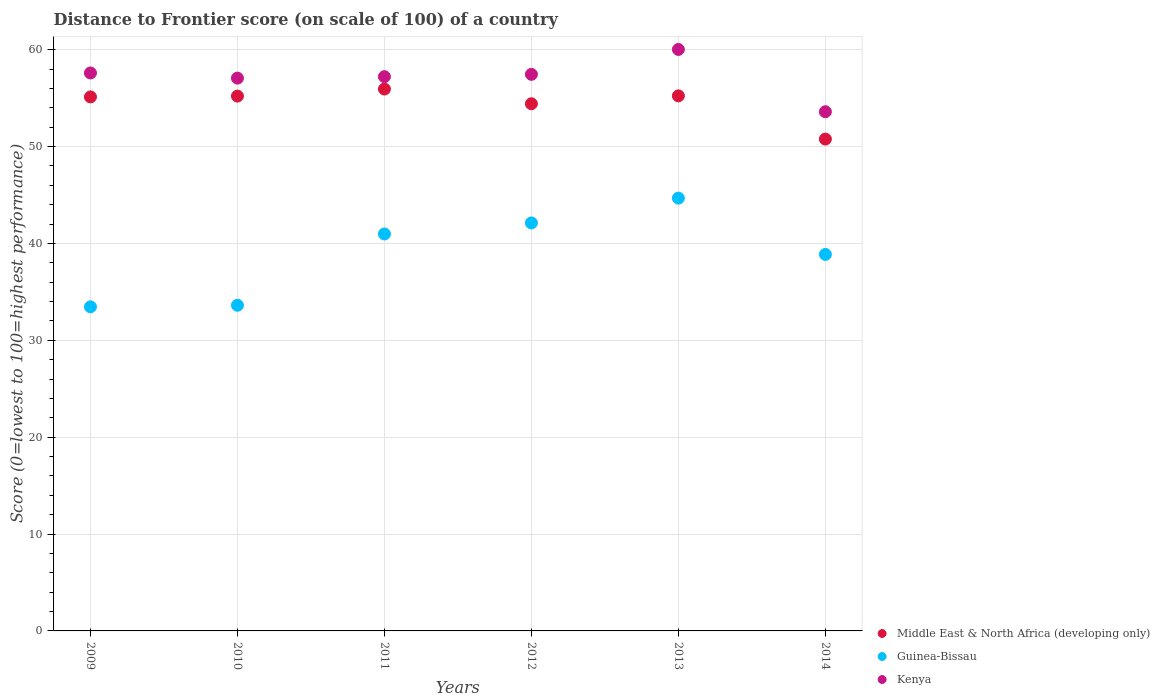How many different coloured dotlines are there?
Give a very brief answer. 3. Is the number of dotlines equal to the number of legend labels?
Your answer should be compact. Yes. What is the distance to frontier score of in Middle East & North Africa (developing only) in 2010?
Ensure brevity in your answer.  55.22. Across all years, what is the maximum distance to frontier score of in Middle East & North Africa (developing only)?
Your answer should be compact. 55.94. Across all years, what is the minimum distance to frontier score of in Guinea-Bissau?
Ensure brevity in your answer.  33.46. In which year was the distance to frontier score of in Guinea-Bissau maximum?
Make the answer very short. 2013. In which year was the distance to frontier score of in Middle East & North Africa (developing only) minimum?
Keep it short and to the point. 2014. What is the total distance to frontier score of in Middle East & North Africa (developing only) in the graph?
Provide a short and direct response. 326.72. What is the difference between the distance to frontier score of in Guinea-Bissau in 2010 and that in 2012?
Give a very brief answer. -8.5. What is the difference between the distance to frontier score of in Guinea-Bissau in 2014 and the distance to frontier score of in Kenya in 2010?
Your answer should be very brief. -18.2. What is the average distance to frontier score of in Middle East & North Africa (developing only) per year?
Offer a terse response. 54.45. In the year 2010, what is the difference between the distance to frontier score of in Kenya and distance to frontier score of in Guinea-Bissau?
Your answer should be very brief. 23.45. What is the ratio of the distance to frontier score of in Guinea-Bissau in 2009 to that in 2012?
Provide a succinct answer. 0.79. What is the difference between the highest and the second highest distance to frontier score of in Guinea-Bissau?
Your answer should be compact. 2.56. What is the difference between the highest and the lowest distance to frontier score of in Kenya?
Offer a very short reply. 6.43. In how many years, is the distance to frontier score of in Middle East & North Africa (developing only) greater than the average distance to frontier score of in Middle East & North Africa (developing only) taken over all years?
Offer a very short reply. 4. Is it the case that in every year, the sum of the distance to frontier score of in Guinea-Bissau and distance to frontier score of in Kenya  is greater than the distance to frontier score of in Middle East & North Africa (developing only)?
Keep it short and to the point. Yes. Does the distance to frontier score of in Guinea-Bissau monotonically increase over the years?
Provide a succinct answer. No. Is the distance to frontier score of in Guinea-Bissau strictly less than the distance to frontier score of in Kenya over the years?
Your answer should be compact. Yes. How many dotlines are there?
Give a very brief answer. 3. How many years are there in the graph?
Give a very brief answer. 6. Does the graph contain any zero values?
Provide a short and direct response. No. Where does the legend appear in the graph?
Your response must be concise. Bottom right. How many legend labels are there?
Ensure brevity in your answer.  3. How are the legend labels stacked?
Your answer should be very brief. Vertical. What is the title of the graph?
Ensure brevity in your answer.  Distance to Frontier score (on scale of 100) of a country. Does "Sudan" appear as one of the legend labels in the graph?
Your answer should be compact. No. What is the label or title of the X-axis?
Give a very brief answer. Years. What is the label or title of the Y-axis?
Your answer should be compact. Score (0=lowest to 100=highest performance). What is the Score (0=lowest to 100=highest performance) of Middle East & North Africa (developing only) in 2009?
Keep it short and to the point. 55.13. What is the Score (0=lowest to 100=highest performance) of Guinea-Bissau in 2009?
Give a very brief answer. 33.46. What is the Score (0=lowest to 100=highest performance) in Kenya in 2009?
Your answer should be compact. 57.6. What is the Score (0=lowest to 100=highest performance) in Middle East & North Africa (developing only) in 2010?
Your response must be concise. 55.22. What is the Score (0=lowest to 100=highest performance) of Guinea-Bissau in 2010?
Provide a succinct answer. 33.62. What is the Score (0=lowest to 100=highest performance) in Kenya in 2010?
Your answer should be compact. 57.07. What is the Score (0=lowest to 100=highest performance) in Middle East & North Africa (developing only) in 2011?
Offer a terse response. 55.94. What is the Score (0=lowest to 100=highest performance) of Guinea-Bissau in 2011?
Make the answer very short. 40.98. What is the Score (0=lowest to 100=highest performance) of Kenya in 2011?
Make the answer very short. 57.22. What is the Score (0=lowest to 100=highest performance) of Middle East & North Africa (developing only) in 2012?
Your answer should be very brief. 54.42. What is the Score (0=lowest to 100=highest performance) in Guinea-Bissau in 2012?
Make the answer very short. 42.12. What is the Score (0=lowest to 100=highest performance) of Kenya in 2012?
Your response must be concise. 57.46. What is the Score (0=lowest to 100=highest performance) of Middle East & North Africa (developing only) in 2013?
Ensure brevity in your answer.  55.24. What is the Score (0=lowest to 100=highest performance) in Guinea-Bissau in 2013?
Provide a short and direct response. 44.68. What is the Score (0=lowest to 100=highest performance) of Kenya in 2013?
Make the answer very short. 60.03. What is the Score (0=lowest to 100=highest performance) in Middle East & North Africa (developing only) in 2014?
Your response must be concise. 50.78. What is the Score (0=lowest to 100=highest performance) in Guinea-Bissau in 2014?
Make the answer very short. 38.87. What is the Score (0=lowest to 100=highest performance) of Kenya in 2014?
Provide a succinct answer. 53.6. Across all years, what is the maximum Score (0=lowest to 100=highest performance) in Middle East & North Africa (developing only)?
Make the answer very short. 55.94. Across all years, what is the maximum Score (0=lowest to 100=highest performance) of Guinea-Bissau?
Ensure brevity in your answer.  44.68. Across all years, what is the maximum Score (0=lowest to 100=highest performance) of Kenya?
Your answer should be very brief. 60.03. Across all years, what is the minimum Score (0=lowest to 100=highest performance) of Middle East & North Africa (developing only)?
Make the answer very short. 50.78. Across all years, what is the minimum Score (0=lowest to 100=highest performance) of Guinea-Bissau?
Provide a succinct answer. 33.46. Across all years, what is the minimum Score (0=lowest to 100=highest performance) in Kenya?
Provide a succinct answer. 53.6. What is the total Score (0=lowest to 100=highest performance) in Middle East & North Africa (developing only) in the graph?
Provide a short and direct response. 326.72. What is the total Score (0=lowest to 100=highest performance) in Guinea-Bissau in the graph?
Offer a very short reply. 233.73. What is the total Score (0=lowest to 100=highest performance) in Kenya in the graph?
Your answer should be very brief. 342.98. What is the difference between the Score (0=lowest to 100=highest performance) of Middle East & North Africa (developing only) in 2009 and that in 2010?
Ensure brevity in your answer.  -0.08. What is the difference between the Score (0=lowest to 100=highest performance) of Guinea-Bissau in 2009 and that in 2010?
Keep it short and to the point. -0.16. What is the difference between the Score (0=lowest to 100=highest performance) in Kenya in 2009 and that in 2010?
Provide a short and direct response. 0.53. What is the difference between the Score (0=lowest to 100=highest performance) of Middle East & North Africa (developing only) in 2009 and that in 2011?
Provide a short and direct response. -0.81. What is the difference between the Score (0=lowest to 100=highest performance) in Guinea-Bissau in 2009 and that in 2011?
Provide a short and direct response. -7.52. What is the difference between the Score (0=lowest to 100=highest performance) of Kenya in 2009 and that in 2011?
Your answer should be very brief. 0.38. What is the difference between the Score (0=lowest to 100=highest performance) in Middle East & North Africa (developing only) in 2009 and that in 2012?
Offer a very short reply. 0.71. What is the difference between the Score (0=lowest to 100=highest performance) in Guinea-Bissau in 2009 and that in 2012?
Keep it short and to the point. -8.66. What is the difference between the Score (0=lowest to 100=highest performance) in Kenya in 2009 and that in 2012?
Keep it short and to the point. 0.14. What is the difference between the Score (0=lowest to 100=highest performance) of Middle East & North Africa (developing only) in 2009 and that in 2013?
Your response must be concise. -0.11. What is the difference between the Score (0=lowest to 100=highest performance) of Guinea-Bissau in 2009 and that in 2013?
Ensure brevity in your answer.  -11.22. What is the difference between the Score (0=lowest to 100=highest performance) of Kenya in 2009 and that in 2013?
Keep it short and to the point. -2.43. What is the difference between the Score (0=lowest to 100=highest performance) in Middle East & North Africa (developing only) in 2009 and that in 2014?
Keep it short and to the point. 4.35. What is the difference between the Score (0=lowest to 100=highest performance) in Guinea-Bissau in 2009 and that in 2014?
Make the answer very short. -5.41. What is the difference between the Score (0=lowest to 100=highest performance) of Kenya in 2009 and that in 2014?
Keep it short and to the point. 4. What is the difference between the Score (0=lowest to 100=highest performance) of Middle East & North Africa (developing only) in 2010 and that in 2011?
Make the answer very short. -0.73. What is the difference between the Score (0=lowest to 100=highest performance) in Guinea-Bissau in 2010 and that in 2011?
Give a very brief answer. -7.36. What is the difference between the Score (0=lowest to 100=highest performance) of Middle East & North Africa (developing only) in 2010 and that in 2012?
Offer a terse response. 0.79. What is the difference between the Score (0=lowest to 100=highest performance) of Kenya in 2010 and that in 2012?
Your answer should be compact. -0.39. What is the difference between the Score (0=lowest to 100=highest performance) of Middle East & North Africa (developing only) in 2010 and that in 2013?
Your response must be concise. -0.02. What is the difference between the Score (0=lowest to 100=highest performance) in Guinea-Bissau in 2010 and that in 2013?
Your response must be concise. -11.06. What is the difference between the Score (0=lowest to 100=highest performance) of Kenya in 2010 and that in 2013?
Your response must be concise. -2.96. What is the difference between the Score (0=lowest to 100=highest performance) in Middle East & North Africa (developing only) in 2010 and that in 2014?
Make the answer very short. 4.44. What is the difference between the Score (0=lowest to 100=highest performance) of Guinea-Bissau in 2010 and that in 2014?
Your answer should be compact. -5.25. What is the difference between the Score (0=lowest to 100=highest performance) in Kenya in 2010 and that in 2014?
Provide a succinct answer. 3.47. What is the difference between the Score (0=lowest to 100=highest performance) of Middle East & North Africa (developing only) in 2011 and that in 2012?
Give a very brief answer. 1.52. What is the difference between the Score (0=lowest to 100=highest performance) of Guinea-Bissau in 2011 and that in 2012?
Offer a very short reply. -1.14. What is the difference between the Score (0=lowest to 100=highest performance) in Kenya in 2011 and that in 2012?
Your response must be concise. -0.24. What is the difference between the Score (0=lowest to 100=highest performance) of Middle East & North Africa (developing only) in 2011 and that in 2013?
Your answer should be compact. 0.71. What is the difference between the Score (0=lowest to 100=highest performance) of Guinea-Bissau in 2011 and that in 2013?
Offer a terse response. -3.7. What is the difference between the Score (0=lowest to 100=highest performance) in Kenya in 2011 and that in 2013?
Provide a succinct answer. -2.81. What is the difference between the Score (0=lowest to 100=highest performance) of Middle East & North Africa (developing only) in 2011 and that in 2014?
Ensure brevity in your answer.  5.17. What is the difference between the Score (0=lowest to 100=highest performance) of Guinea-Bissau in 2011 and that in 2014?
Provide a short and direct response. 2.11. What is the difference between the Score (0=lowest to 100=highest performance) in Kenya in 2011 and that in 2014?
Offer a terse response. 3.62. What is the difference between the Score (0=lowest to 100=highest performance) in Middle East & North Africa (developing only) in 2012 and that in 2013?
Offer a very short reply. -0.81. What is the difference between the Score (0=lowest to 100=highest performance) of Guinea-Bissau in 2012 and that in 2013?
Make the answer very short. -2.56. What is the difference between the Score (0=lowest to 100=highest performance) of Kenya in 2012 and that in 2013?
Offer a very short reply. -2.57. What is the difference between the Score (0=lowest to 100=highest performance) in Middle East & North Africa (developing only) in 2012 and that in 2014?
Offer a terse response. 3.65. What is the difference between the Score (0=lowest to 100=highest performance) of Guinea-Bissau in 2012 and that in 2014?
Offer a terse response. 3.25. What is the difference between the Score (0=lowest to 100=highest performance) of Kenya in 2012 and that in 2014?
Provide a short and direct response. 3.86. What is the difference between the Score (0=lowest to 100=highest performance) of Middle East & North Africa (developing only) in 2013 and that in 2014?
Give a very brief answer. 4.46. What is the difference between the Score (0=lowest to 100=highest performance) in Guinea-Bissau in 2013 and that in 2014?
Your response must be concise. 5.81. What is the difference between the Score (0=lowest to 100=highest performance) of Kenya in 2013 and that in 2014?
Provide a short and direct response. 6.43. What is the difference between the Score (0=lowest to 100=highest performance) in Middle East & North Africa (developing only) in 2009 and the Score (0=lowest to 100=highest performance) in Guinea-Bissau in 2010?
Your answer should be very brief. 21.51. What is the difference between the Score (0=lowest to 100=highest performance) of Middle East & North Africa (developing only) in 2009 and the Score (0=lowest to 100=highest performance) of Kenya in 2010?
Your answer should be compact. -1.94. What is the difference between the Score (0=lowest to 100=highest performance) in Guinea-Bissau in 2009 and the Score (0=lowest to 100=highest performance) in Kenya in 2010?
Offer a terse response. -23.61. What is the difference between the Score (0=lowest to 100=highest performance) in Middle East & North Africa (developing only) in 2009 and the Score (0=lowest to 100=highest performance) in Guinea-Bissau in 2011?
Provide a succinct answer. 14.15. What is the difference between the Score (0=lowest to 100=highest performance) in Middle East & North Africa (developing only) in 2009 and the Score (0=lowest to 100=highest performance) in Kenya in 2011?
Keep it short and to the point. -2.09. What is the difference between the Score (0=lowest to 100=highest performance) in Guinea-Bissau in 2009 and the Score (0=lowest to 100=highest performance) in Kenya in 2011?
Offer a terse response. -23.76. What is the difference between the Score (0=lowest to 100=highest performance) of Middle East & North Africa (developing only) in 2009 and the Score (0=lowest to 100=highest performance) of Guinea-Bissau in 2012?
Offer a very short reply. 13.01. What is the difference between the Score (0=lowest to 100=highest performance) of Middle East & North Africa (developing only) in 2009 and the Score (0=lowest to 100=highest performance) of Kenya in 2012?
Your response must be concise. -2.33. What is the difference between the Score (0=lowest to 100=highest performance) in Middle East & North Africa (developing only) in 2009 and the Score (0=lowest to 100=highest performance) in Guinea-Bissau in 2013?
Your response must be concise. 10.45. What is the difference between the Score (0=lowest to 100=highest performance) of Middle East & North Africa (developing only) in 2009 and the Score (0=lowest to 100=highest performance) of Kenya in 2013?
Keep it short and to the point. -4.9. What is the difference between the Score (0=lowest to 100=highest performance) of Guinea-Bissau in 2009 and the Score (0=lowest to 100=highest performance) of Kenya in 2013?
Your response must be concise. -26.57. What is the difference between the Score (0=lowest to 100=highest performance) of Middle East & North Africa (developing only) in 2009 and the Score (0=lowest to 100=highest performance) of Guinea-Bissau in 2014?
Keep it short and to the point. 16.26. What is the difference between the Score (0=lowest to 100=highest performance) of Middle East & North Africa (developing only) in 2009 and the Score (0=lowest to 100=highest performance) of Kenya in 2014?
Your answer should be very brief. 1.53. What is the difference between the Score (0=lowest to 100=highest performance) in Guinea-Bissau in 2009 and the Score (0=lowest to 100=highest performance) in Kenya in 2014?
Your answer should be compact. -20.14. What is the difference between the Score (0=lowest to 100=highest performance) of Middle East & North Africa (developing only) in 2010 and the Score (0=lowest to 100=highest performance) of Guinea-Bissau in 2011?
Offer a terse response. 14.23. What is the difference between the Score (0=lowest to 100=highest performance) in Middle East & North Africa (developing only) in 2010 and the Score (0=lowest to 100=highest performance) in Kenya in 2011?
Your answer should be very brief. -2. What is the difference between the Score (0=lowest to 100=highest performance) in Guinea-Bissau in 2010 and the Score (0=lowest to 100=highest performance) in Kenya in 2011?
Make the answer very short. -23.6. What is the difference between the Score (0=lowest to 100=highest performance) in Middle East & North Africa (developing only) in 2010 and the Score (0=lowest to 100=highest performance) in Guinea-Bissau in 2012?
Make the answer very short. 13.1. What is the difference between the Score (0=lowest to 100=highest performance) in Middle East & North Africa (developing only) in 2010 and the Score (0=lowest to 100=highest performance) in Kenya in 2012?
Provide a succinct answer. -2.25. What is the difference between the Score (0=lowest to 100=highest performance) of Guinea-Bissau in 2010 and the Score (0=lowest to 100=highest performance) of Kenya in 2012?
Offer a terse response. -23.84. What is the difference between the Score (0=lowest to 100=highest performance) of Middle East & North Africa (developing only) in 2010 and the Score (0=lowest to 100=highest performance) of Guinea-Bissau in 2013?
Your response must be concise. 10.54. What is the difference between the Score (0=lowest to 100=highest performance) in Middle East & North Africa (developing only) in 2010 and the Score (0=lowest to 100=highest performance) in Kenya in 2013?
Provide a succinct answer. -4.82. What is the difference between the Score (0=lowest to 100=highest performance) of Guinea-Bissau in 2010 and the Score (0=lowest to 100=highest performance) of Kenya in 2013?
Make the answer very short. -26.41. What is the difference between the Score (0=lowest to 100=highest performance) in Middle East & North Africa (developing only) in 2010 and the Score (0=lowest to 100=highest performance) in Guinea-Bissau in 2014?
Your answer should be very brief. 16.34. What is the difference between the Score (0=lowest to 100=highest performance) in Middle East & North Africa (developing only) in 2010 and the Score (0=lowest to 100=highest performance) in Kenya in 2014?
Offer a very short reply. 1.61. What is the difference between the Score (0=lowest to 100=highest performance) in Guinea-Bissau in 2010 and the Score (0=lowest to 100=highest performance) in Kenya in 2014?
Provide a short and direct response. -19.98. What is the difference between the Score (0=lowest to 100=highest performance) of Middle East & North Africa (developing only) in 2011 and the Score (0=lowest to 100=highest performance) of Guinea-Bissau in 2012?
Your answer should be compact. 13.82. What is the difference between the Score (0=lowest to 100=highest performance) of Middle East & North Africa (developing only) in 2011 and the Score (0=lowest to 100=highest performance) of Kenya in 2012?
Your answer should be compact. -1.52. What is the difference between the Score (0=lowest to 100=highest performance) of Guinea-Bissau in 2011 and the Score (0=lowest to 100=highest performance) of Kenya in 2012?
Your response must be concise. -16.48. What is the difference between the Score (0=lowest to 100=highest performance) in Middle East & North Africa (developing only) in 2011 and the Score (0=lowest to 100=highest performance) in Guinea-Bissau in 2013?
Give a very brief answer. 11.26. What is the difference between the Score (0=lowest to 100=highest performance) of Middle East & North Africa (developing only) in 2011 and the Score (0=lowest to 100=highest performance) of Kenya in 2013?
Give a very brief answer. -4.09. What is the difference between the Score (0=lowest to 100=highest performance) in Guinea-Bissau in 2011 and the Score (0=lowest to 100=highest performance) in Kenya in 2013?
Keep it short and to the point. -19.05. What is the difference between the Score (0=lowest to 100=highest performance) of Middle East & North Africa (developing only) in 2011 and the Score (0=lowest to 100=highest performance) of Guinea-Bissau in 2014?
Your answer should be compact. 17.07. What is the difference between the Score (0=lowest to 100=highest performance) of Middle East & North Africa (developing only) in 2011 and the Score (0=lowest to 100=highest performance) of Kenya in 2014?
Give a very brief answer. 2.34. What is the difference between the Score (0=lowest to 100=highest performance) of Guinea-Bissau in 2011 and the Score (0=lowest to 100=highest performance) of Kenya in 2014?
Ensure brevity in your answer.  -12.62. What is the difference between the Score (0=lowest to 100=highest performance) of Middle East & North Africa (developing only) in 2012 and the Score (0=lowest to 100=highest performance) of Guinea-Bissau in 2013?
Make the answer very short. 9.74. What is the difference between the Score (0=lowest to 100=highest performance) of Middle East & North Africa (developing only) in 2012 and the Score (0=lowest to 100=highest performance) of Kenya in 2013?
Provide a short and direct response. -5.61. What is the difference between the Score (0=lowest to 100=highest performance) in Guinea-Bissau in 2012 and the Score (0=lowest to 100=highest performance) in Kenya in 2013?
Ensure brevity in your answer.  -17.91. What is the difference between the Score (0=lowest to 100=highest performance) of Middle East & North Africa (developing only) in 2012 and the Score (0=lowest to 100=highest performance) of Guinea-Bissau in 2014?
Give a very brief answer. 15.55. What is the difference between the Score (0=lowest to 100=highest performance) of Middle East & North Africa (developing only) in 2012 and the Score (0=lowest to 100=highest performance) of Kenya in 2014?
Offer a terse response. 0.82. What is the difference between the Score (0=lowest to 100=highest performance) of Guinea-Bissau in 2012 and the Score (0=lowest to 100=highest performance) of Kenya in 2014?
Offer a very short reply. -11.48. What is the difference between the Score (0=lowest to 100=highest performance) in Middle East & North Africa (developing only) in 2013 and the Score (0=lowest to 100=highest performance) in Guinea-Bissau in 2014?
Offer a terse response. 16.37. What is the difference between the Score (0=lowest to 100=highest performance) of Middle East & North Africa (developing only) in 2013 and the Score (0=lowest to 100=highest performance) of Kenya in 2014?
Provide a succinct answer. 1.64. What is the difference between the Score (0=lowest to 100=highest performance) of Guinea-Bissau in 2013 and the Score (0=lowest to 100=highest performance) of Kenya in 2014?
Provide a short and direct response. -8.92. What is the average Score (0=lowest to 100=highest performance) in Middle East & North Africa (developing only) per year?
Make the answer very short. 54.45. What is the average Score (0=lowest to 100=highest performance) in Guinea-Bissau per year?
Offer a very short reply. 38.95. What is the average Score (0=lowest to 100=highest performance) of Kenya per year?
Your answer should be very brief. 57.16. In the year 2009, what is the difference between the Score (0=lowest to 100=highest performance) in Middle East & North Africa (developing only) and Score (0=lowest to 100=highest performance) in Guinea-Bissau?
Your response must be concise. 21.67. In the year 2009, what is the difference between the Score (0=lowest to 100=highest performance) of Middle East & North Africa (developing only) and Score (0=lowest to 100=highest performance) of Kenya?
Keep it short and to the point. -2.47. In the year 2009, what is the difference between the Score (0=lowest to 100=highest performance) in Guinea-Bissau and Score (0=lowest to 100=highest performance) in Kenya?
Make the answer very short. -24.14. In the year 2010, what is the difference between the Score (0=lowest to 100=highest performance) of Middle East & North Africa (developing only) and Score (0=lowest to 100=highest performance) of Guinea-Bissau?
Your answer should be very brief. 21.59. In the year 2010, what is the difference between the Score (0=lowest to 100=highest performance) of Middle East & North Africa (developing only) and Score (0=lowest to 100=highest performance) of Kenya?
Keep it short and to the point. -1.85. In the year 2010, what is the difference between the Score (0=lowest to 100=highest performance) of Guinea-Bissau and Score (0=lowest to 100=highest performance) of Kenya?
Your response must be concise. -23.45. In the year 2011, what is the difference between the Score (0=lowest to 100=highest performance) of Middle East & North Africa (developing only) and Score (0=lowest to 100=highest performance) of Guinea-Bissau?
Your answer should be very brief. 14.96. In the year 2011, what is the difference between the Score (0=lowest to 100=highest performance) in Middle East & North Africa (developing only) and Score (0=lowest to 100=highest performance) in Kenya?
Give a very brief answer. -1.28. In the year 2011, what is the difference between the Score (0=lowest to 100=highest performance) of Guinea-Bissau and Score (0=lowest to 100=highest performance) of Kenya?
Your answer should be compact. -16.24. In the year 2012, what is the difference between the Score (0=lowest to 100=highest performance) in Middle East & North Africa (developing only) and Score (0=lowest to 100=highest performance) in Guinea-Bissau?
Provide a succinct answer. 12.3. In the year 2012, what is the difference between the Score (0=lowest to 100=highest performance) of Middle East & North Africa (developing only) and Score (0=lowest to 100=highest performance) of Kenya?
Offer a terse response. -3.04. In the year 2012, what is the difference between the Score (0=lowest to 100=highest performance) in Guinea-Bissau and Score (0=lowest to 100=highest performance) in Kenya?
Provide a short and direct response. -15.34. In the year 2013, what is the difference between the Score (0=lowest to 100=highest performance) in Middle East & North Africa (developing only) and Score (0=lowest to 100=highest performance) in Guinea-Bissau?
Keep it short and to the point. 10.56. In the year 2013, what is the difference between the Score (0=lowest to 100=highest performance) in Middle East & North Africa (developing only) and Score (0=lowest to 100=highest performance) in Kenya?
Provide a short and direct response. -4.79. In the year 2013, what is the difference between the Score (0=lowest to 100=highest performance) of Guinea-Bissau and Score (0=lowest to 100=highest performance) of Kenya?
Offer a terse response. -15.35. In the year 2014, what is the difference between the Score (0=lowest to 100=highest performance) of Middle East & North Africa (developing only) and Score (0=lowest to 100=highest performance) of Guinea-Bissau?
Provide a succinct answer. 11.91. In the year 2014, what is the difference between the Score (0=lowest to 100=highest performance) in Middle East & North Africa (developing only) and Score (0=lowest to 100=highest performance) in Kenya?
Keep it short and to the point. -2.82. In the year 2014, what is the difference between the Score (0=lowest to 100=highest performance) in Guinea-Bissau and Score (0=lowest to 100=highest performance) in Kenya?
Your answer should be very brief. -14.73. What is the ratio of the Score (0=lowest to 100=highest performance) of Kenya in 2009 to that in 2010?
Give a very brief answer. 1.01. What is the ratio of the Score (0=lowest to 100=highest performance) in Middle East & North Africa (developing only) in 2009 to that in 2011?
Make the answer very short. 0.99. What is the ratio of the Score (0=lowest to 100=highest performance) in Guinea-Bissau in 2009 to that in 2011?
Make the answer very short. 0.82. What is the ratio of the Score (0=lowest to 100=highest performance) of Kenya in 2009 to that in 2011?
Your answer should be compact. 1.01. What is the ratio of the Score (0=lowest to 100=highest performance) in Guinea-Bissau in 2009 to that in 2012?
Your answer should be compact. 0.79. What is the ratio of the Score (0=lowest to 100=highest performance) of Kenya in 2009 to that in 2012?
Your answer should be very brief. 1. What is the ratio of the Score (0=lowest to 100=highest performance) in Guinea-Bissau in 2009 to that in 2013?
Offer a very short reply. 0.75. What is the ratio of the Score (0=lowest to 100=highest performance) in Kenya in 2009 to that in 2013?
Offer a very short reply. 0.96. What is the ratio of the Score (0=lowest to 100=highest performance) in Middle East & North Africa (developing only) in 2009 to that in 2014?
Make the answer very short. 1.09. What is the ratio of the Score (0=lowest to 100=highest performance) in Guinea-Bissau in 2009 to that in 2014?
Keep it short and to the point. 0.86. What is the ratio of the Score (0=lowest to 100=highest performance) in Kenya in 2009 to that in 2014?
Keep it short and to the point. 1.07. What is the ratio of the Score (0=lowest to 100=highest performance) of Guinea-Bissau in 2010 to that in 2011?
Your answer should be very brief. 0.82. What is the ratio of the Score (0=lowest to 100=highest performance) in Kenya in 2010 to that in 2011?
Provide a short and direct response. 1. What is the ratio of the Score (0=lowest to 100=highest performance) in Middle East & North Africa (developing only) in 2010 to that in 2012?
Make the answer very short. 1.01. What is the ratio of the Score (0=lowest to 100=highest performance) in Guinea-Bissau in 2010 to that in 2012?
Provide a short and direct response. 0.8. What is the ratio of the Score (0=lowest to 100=highest performance) in Middle East & North Africa (developing only) in 2010 to that in 2013?
Your response must be concise. 1. What is the ratio of the Score (0=lowest to 100=highest performance) of Guinea-Bissau in 2010 to that in 2013?
Your answer should be compact. 0.75. What is the ratio of the Score (0=lowest to 100=highest performance) in Kenya in 2010 to that in 2013?
Give a very brief answer. 0.95. What is the ratio of the Score (0=lowest to 100=highest performance) in Middle East & North Africa (developing only) in 2010 to that in 2014?
Make the answer very short. 1.09. What is the ratio of the Score (0=lowest to 100=highest performance) of Guinea-Bissau in 2010 to that in 2014?
Your answer should be very brief. 0.86. What is the ratio of the Score (0=lowest to 100=highest performance) of Kenya in 2010 to that in 2014?
Ensure brevity in your answer.  1.06. What is the ratio of the Score (0=lowest to 100=highest performance) in Middle East & North Africa (developing only) in 2011 to that in 2012?
Make the answer very short. 1.03. What is the ratio of the Score (0=lowest to 100=highest performance) in Guinea-Bissau in 2011 to that in 2012?
Keep it short and to the point. 0.97. What is the ratio of the Score (0=lowest to 100=highest performance) of Kenya in 2011 to that in 2012?
Your response must be concise. 1. What is the ratio of the Score (0=lowest to 100=highest performance) in Middle East & North Africa (developing only) in 2011 to that in 2013?
Give a very brief answer. 1.01. What is the ratio of the Score (0=lowest to 100=highest performance) in Guinea-Bissau in 2011 to that in 2013?
Give a very brief answer. 0.92. What is the ratio of the Score (0=lowest to 100=highest performance) of Kenya in 2011 to that in 2013?
Make the answer very short. 0.95. What is the ratio of the Score (0=lowest to 100=highest performance) in Middle East & North Africa (developing only) in 2011 to that in 2014?
Your answer should be compact. 1.1. What is the ratio of the Score (0=lowest to 100=highest performance) of Guinea-Bissau in 2011 to that in 2014?
Keep it short and to the point. 1.05. What is the ratio of the Score (0=lowest to 100=highest performance) of Kenya in 2011 to that in 2014?
Provide a short and direct response. 1.07. What is the ratio of the Score (0=lowest to 100=highest performance) in Middle East & North Africa (developing only) in 2012 to that in 2013?
Offer a terse response. 0.99. What is the ratio of the Score (0=lowest to 100=highest performance) in Guinea-Bissau in 2012 to that in 2013?
Give a very brief answer. 0.94. What is the ratio of the Score (0=lowest to 100=highest performance) in Kenya in 2012 to that in 2013?
Keep it short and to the point. 0.96. What is the ratio of the Score (0=lowest to 100=highest performance) in Middle East & North Africa (developing only) in 2012 to that in 2014?
Offer a very short reply. 1.07. What is the ratio of the Score (0=lowest to 100=highest performance) in Guinea-Bissau in 2012 to that in 2014?
Provide a succinct answer. 1.08. What is the ratio of the Score (0=lowest to 100=highest performance) of Kenya in 2012 to that in 2014?
Make the answer very short. 1.07. What is the ratio of the Score (0=lowest to 100=highest performance) of Middle East & North Africa (developing only) in 2013 to that in 2014?
Make the answer very short. 1.09. What is the ratio of the Score (0=lowest to 100=highest performance) in Guinea-Bissau in 2013 to that in 2014?
Keep it short and to the point. 1.15. What is the ratio of the Score (0=lowest to 100=highest performance) in Kenya in 2013 to that in 2014?
Provide a succinct answer. 1.12. What is the difference between the highest and the second highest Score (0=lowest to 100=highest performance) of Middle East & North Africa (developing only)?
Keep it short and to the point. 0.71. What is the difference between the highest and the second highest Score (0=lowest to 100=highest performance) of Guinea-Bissau?
Your answer should be compact. 2.56. What is the difference between the highest and the second highest Score (0=lowest to 100=highest performance) in Kenya?
Offer a terse response. 2.43. What is the difference between the highest and the lowest Score (0=lowest to 100=highest performance) in Middle East & North Africa (developing only)?
Offer a terse response. 5.17. What is the difference between the highest and the lowest Score (0=lowest to 100=highest performance) of Guinea-Bissau?
Your answer should be very brief. 11.22. What is the difference between the highest and the lowest Score (0=lowest to 100=highest performance) in Kenya?
Your response must be concise. 6.43. 